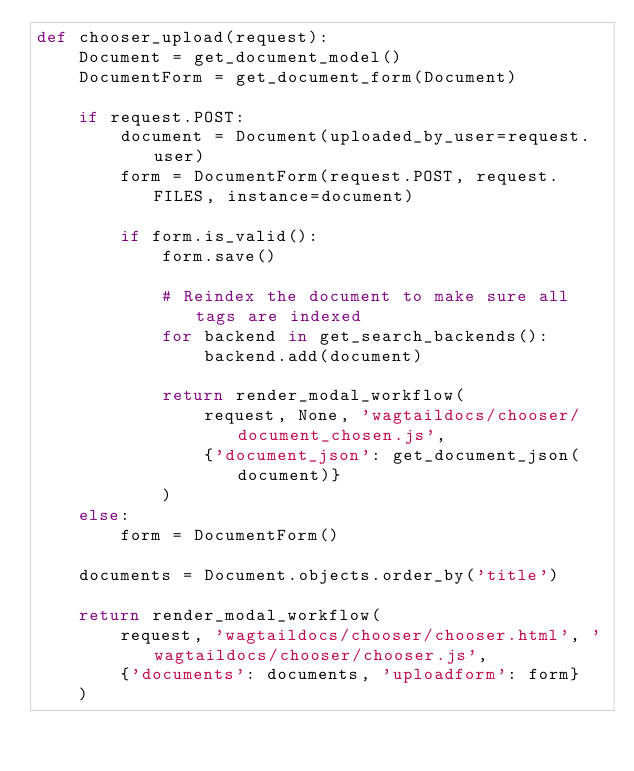Convert code to text. <code><loc_0><loc_0><loc_500><loc_500><_Python_>def chooser_upload(request):
    Document = get_document_model()
    DocumentForm = get_document_form(Document)

    if request.POST:
        document = Document(uploaded_by_user=request.user)
        form = DocumentForm(request.POST, request.FILES, instance=document)

        if form.is_valid():
            form.save()

            # Reindex the document to make sure all tags are indexed
            for backend in get_search_backends():
                backend.add(document)

            return render_modal_workflow(
                request, None, 'wagtaildocs/chooser/document_chosen.js',
                {'document_json': get_document_json(document)}
            )
    else:
        form = DocumentForm()

    documents = Document.objects.order_by('title')

    return render_modal_workflow(
        request, 'wagtaildocs/chooser/chooser.html', 'wagtaildocs/chooser/chooser.js',
        {'documents': documents, 'uploadform': form}
    )
</code> 